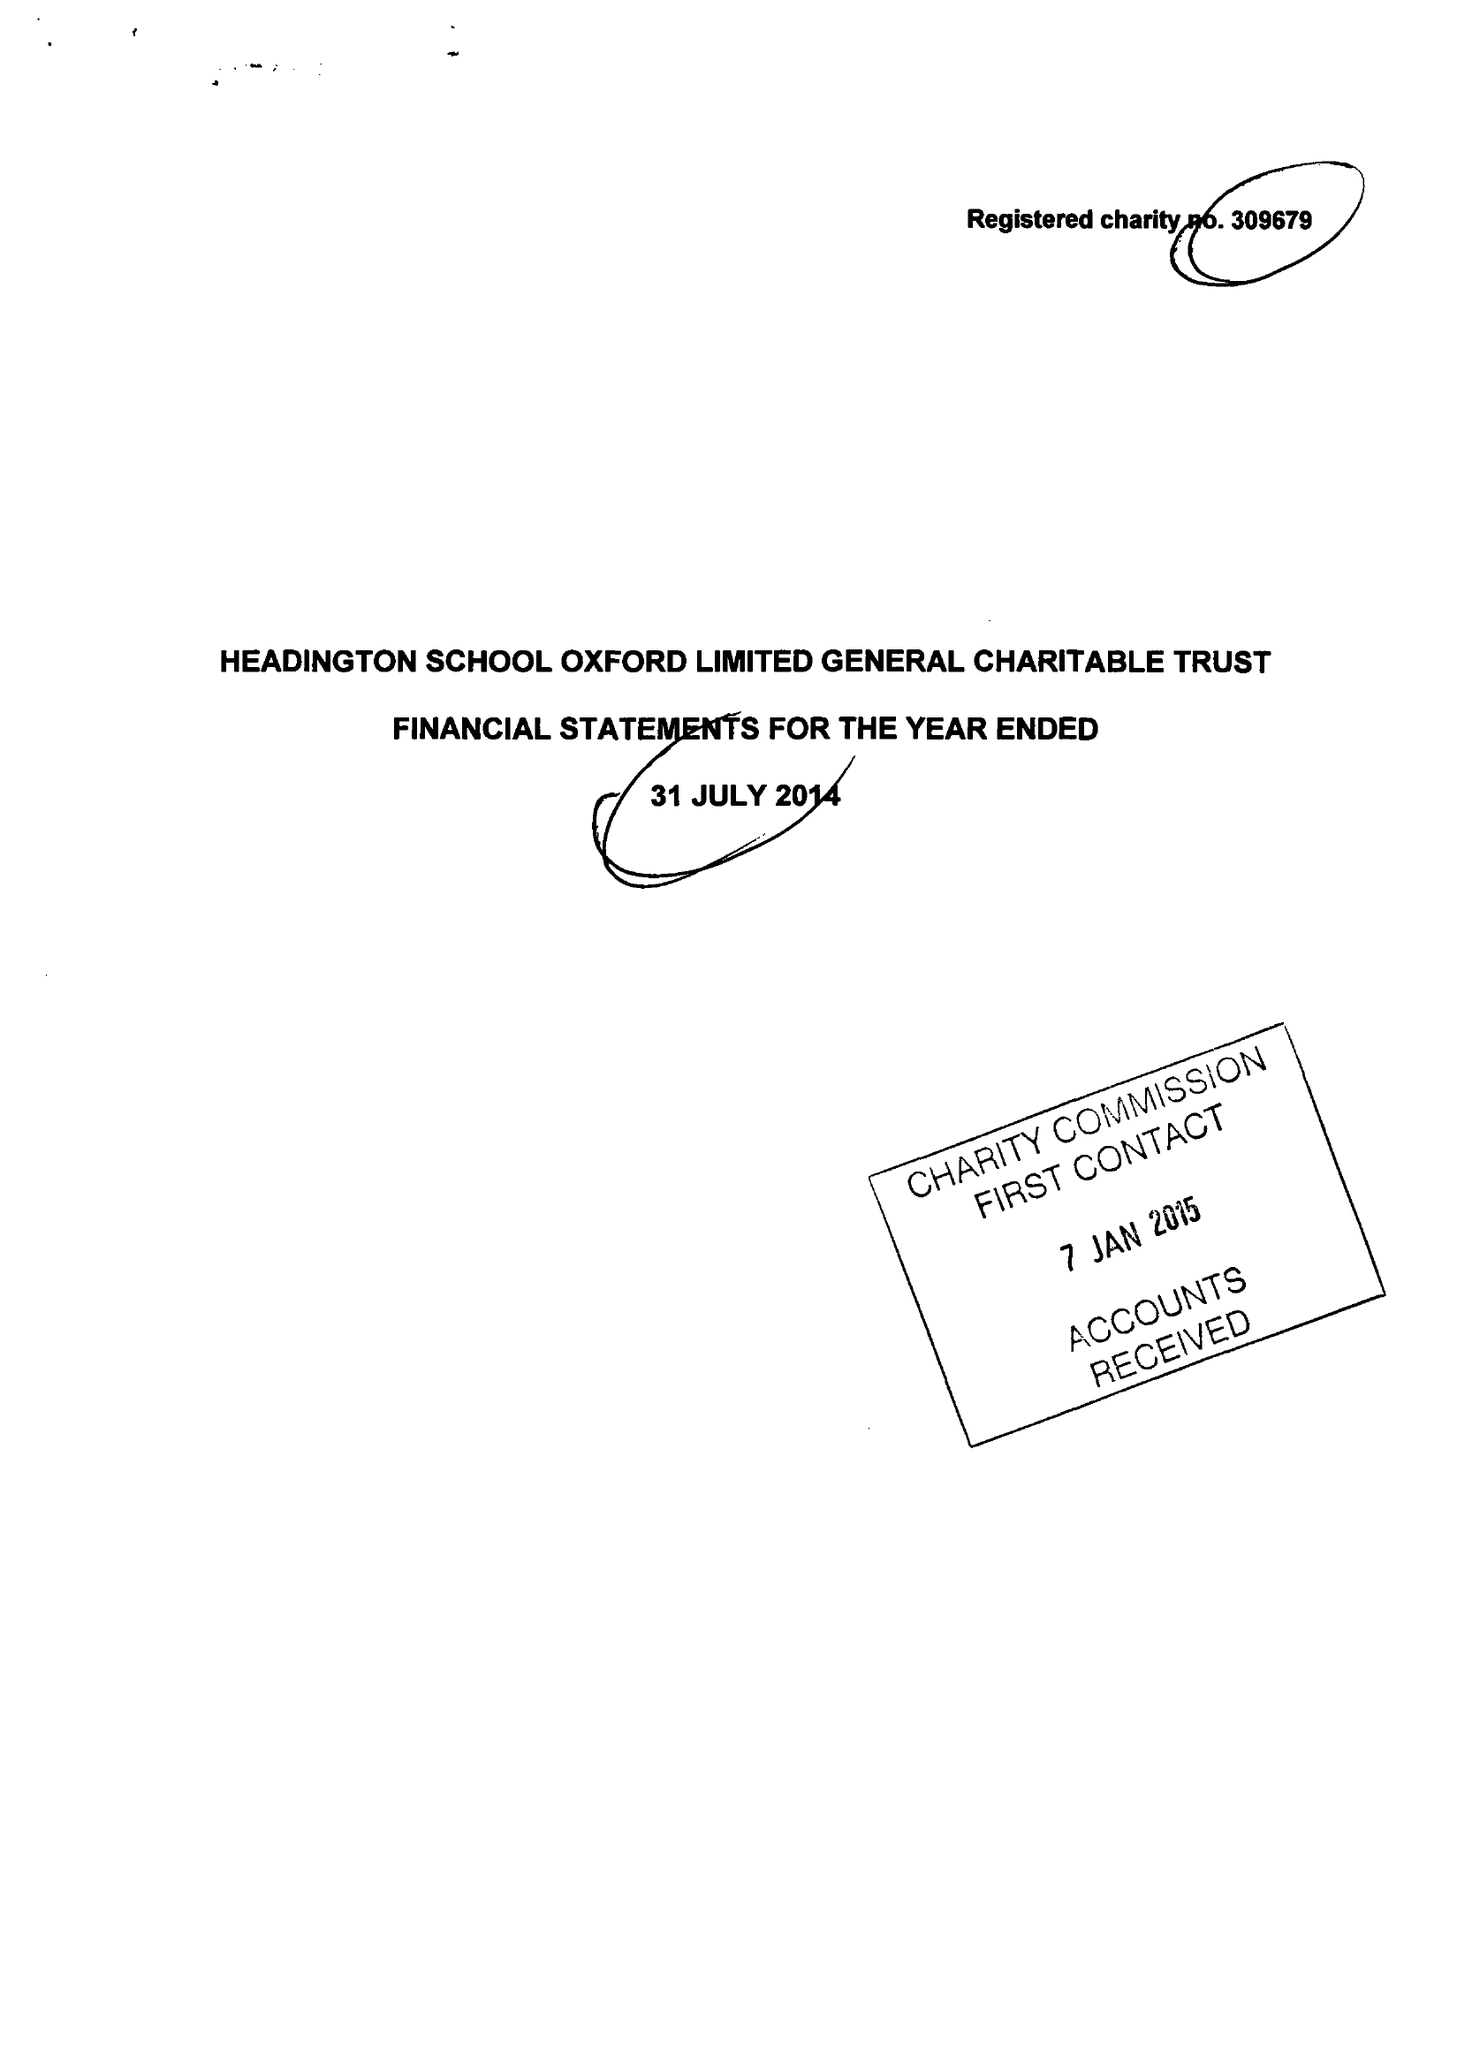What is the value for the report_date?
Answer the question using a single word or phrase. 2014-07-31 